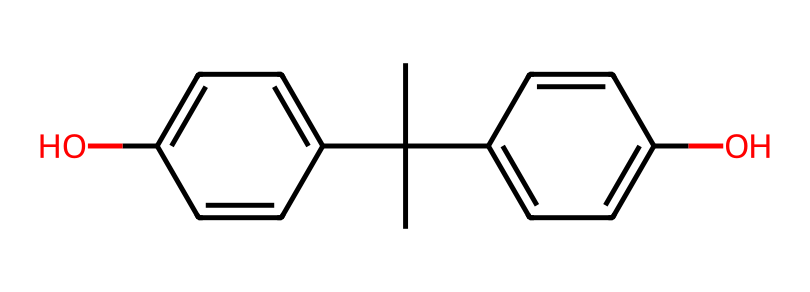What is the chemical name for the compound represented? The SMILES notation indicates a compound with a central carbon atom attached to two aromatic rings (c1ccc(O)cc1) and further branched carbon groups (CC(C)). This identifies it as Bisphenol A (BPA).
Answer: Bisphenol A How many hydroxyl (-OH) groups are present in this structure? The visual representation of the structure indicates two hydroxyl groups (–OH) are present, one on each aromatic ring, which can be observed in the c1ccc(O)cc1 sections of the SMILES.
Answer: 2 What type of functional group is evident in this molecule? The presence of hydroxyl groups (-OH) indicates that this molecule contains functional groups characteristic of phenols, which is evident from the structure showcasing these groups attached to the aromatic rings.
Answer: hydroxyl How many carbon atoms are in the molecule? Counting from the SMILES notation, there are a total of 15 carbon atoms; 13 from the aromatic rings and branched chain, and 2 from the central carbon (CC(C)).
Answer: 15 Which feature of this molecule increases the risk of endocrine disruption? The hydroxyl groups (-OH) bonded to the aromatic rings are often responsible for the endocrine-disrupting properties of BPA as they can mimic estrogen and bind to its receptors.
Answer: hydroxyl groups Does this compound have any alkyl substituents? Yes, there are alkyl substituents present in the structure, specifically the tertiary butyl group represented by CC(C), which branches off the central carbon atom.
Answer: yes What is a common application of this compound? Bisphenol A (BPA) is widely used in the production of polycarbonate plastics and epoxy resins, which are common in many consumer products, including plastic water bottles.
Answer: plastic water bottles 